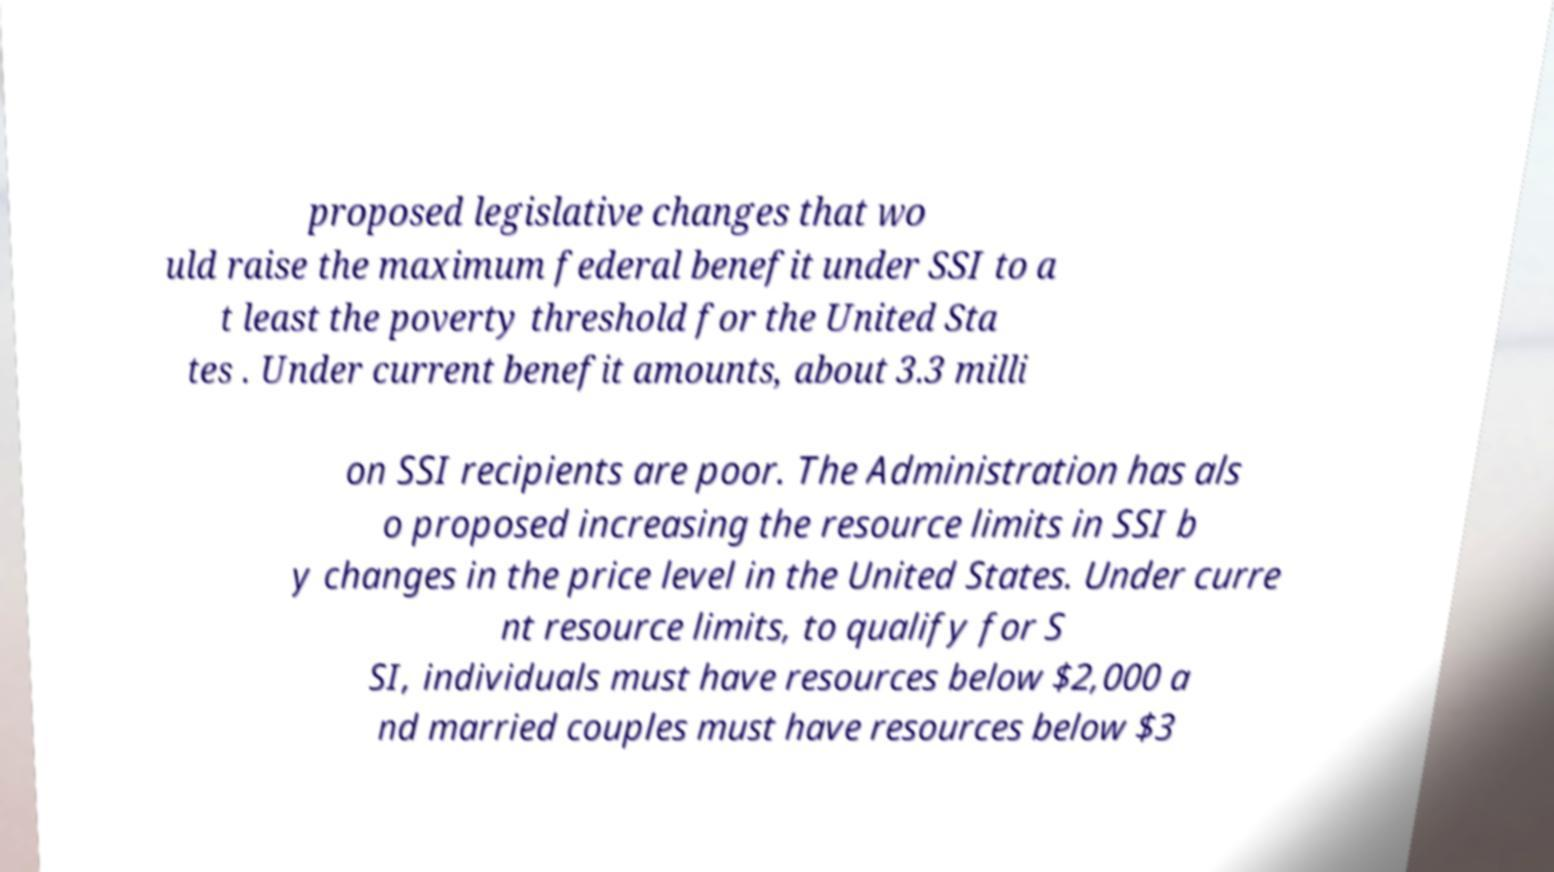I need the written content from this picture converted into text. Can you do that? proposed legislative changes that wo uld raise the maximum federal benefit under SSI to a t least the poverty threshold for the United Sta tes . Under current benefit amounts, about 3.3 milli on SSI recipients are poor. The Administration has als o proposed increasing the resource limits in SSI b y changes in the price level in the United States. Under curre nt resource limits, to qualify for S SI, individuals must have resources below $2,000 a nd married couples must have resources below $3 